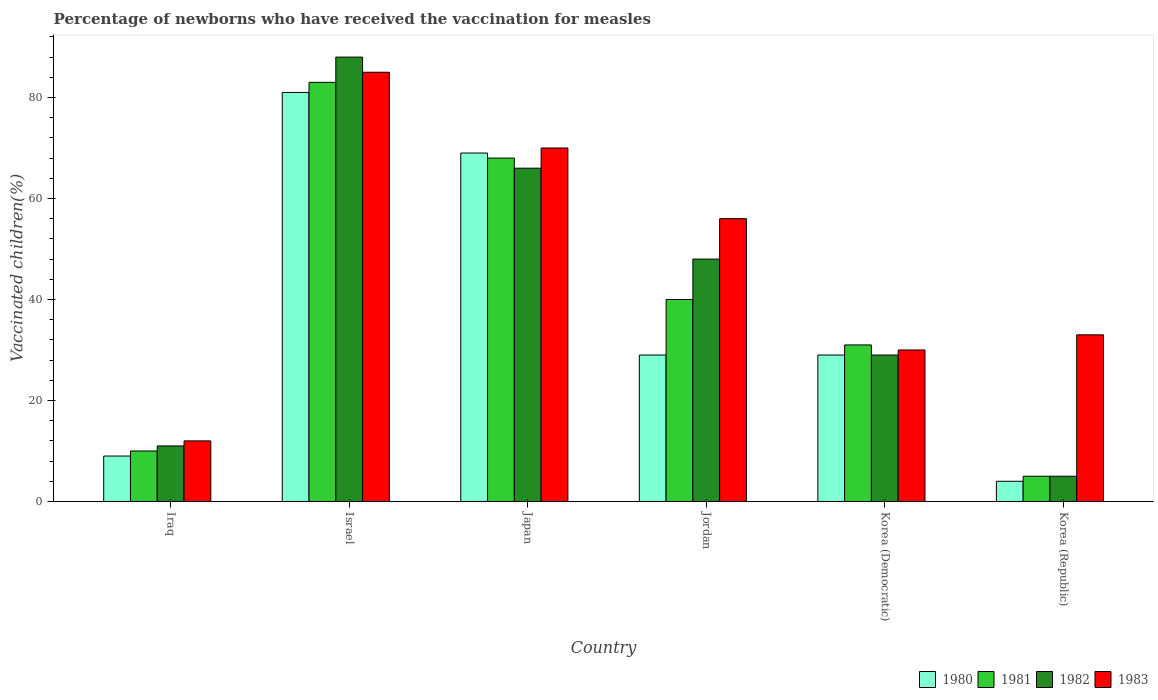How many groups of bars are there?
Make the answer very short. 6. How many bars are there on the 1st tick from the right?
Your answer should be very brief. 4. In how many cases, is the number of bars for a given country not equal to the number of legend labels?
Provide a succinct answer. 0. Across all countries, what is the minimum percentage of vaccinated children in 1982?
Provide a succinct answer. 5. In which country was the percentage of vaccinated children in 1982 minimum?
Your answer should be compact. Korea (Republic). What is the total percentage of vaccinated children in 1981 in the graph?
Offer a very short reply. 237. What is the difference between the percentage of vaccinated children in 1980 in Iraq and the percentage of vaccinated children in 1983 in Jordan?
Offer a terse response. -47. What is the average percentage of vaccinated children in 1983 per country?
Offer a terse response. 47.67. In how many countries, is the percentage of vaccinated children in 1981 greater than 80 %?
Give a very brief answer. 1. In how many countries, is the percentage of vaccinated children in 1981 greater than the average percentage of vaccinated children in 1981 taken over all countries?
Give a very brief answer. 3. Is the sum of the percentage of vaccinated children in 1981 in Iraq and Jordan greater than the maximum percentage of vaccinated children in 1983 across all countries?
Provide a short and direct response. No. How many bars are there?
Offer a very short reply. 24. Are all the bars in the graph horizontal?
Give a very brief answer. No. How many countries are there in the graph?
Your answer should be very brief. 6. Are the values on the major ticks of Y-axis written in scientific E-notation?
Give a very brief answer. No. Does the graph contain grids?
Give a very brief answer. No. How are the legend labels stacked?
Give a very brief answer. Horizontal. What is the title of the graph?
Offer a very short reply. Percentage of newborns who have received the vaccination for measles. What is the label or title of the Y-axis?
Keep it short and to the point. Vaccinated children(%). What is the Vaccinated children(%) in 1980 in Iraq?
Ensure brevity in your answer.  9. What is the Vaccinated children(%) in 1981 in Iraq?
Provide a succinct answer. 10. What is the Vaccinated children(%) of 1980 in Israel?
Make the answer very short. 81. What is the Vaccinated children(%) of 1981 in Israel?
Offer a terse response. 83. What is the Vaccinated children(%) in 1982 in Israel?
Keep it short and to the point. 88. What is the Vaccinated children(%) of 1980 in Japan?
Your answer should be very brief. 69. What is the Vaccinated children(%) in 1981 in Japan?
Give a very brief answer. 68. What is the Vaccinated children(%) of 1983 in Japan?
Make the answer very short. 70. What is the Vaccinated children(%) in 1982 in Jordan?
Give a very brief answer. 48. What is the Vaccinated children(%) in 1980 in Korea (Democratic)?
Your answer should be compact. 29. What is the Vaccinated children(%) in 1981 in Korea (Democratic)?
Give a very brief answer. 31. What is the Vaccinated children(%) in 1982 in Korea (Democratic)?
Ensure brevity in your answer.  29. Across all countries, what is the maximum Vaccinated children(%) of 1980?
Offer a very short reply. 81. Across all countries, what is the maximum Vaccinated children(%) in 1981?
Provide a succinct answer. 83. Across all countries, what is the maximum Vaccinated children(%) of 1982?
Your answer should be very brief. 88. Across all countries, what is the maximum Vaccinated children(%) of 1983?
Provide a short and direct response. 85. Across all countries, what is the minimum Vaccinated children(%) of 1980?
Ensure brevity in your answer.  4. Across all countries, what is the minimum Vaccinated children(%) in 1981?
Offer a terse response. 5. What is the total Vaccinated children(%) of 1980 in the graph?
Make the answer very short. 221. What is the total Vaccinated children(%) in 1981 in the graph?
Make the answer very short. 237. What is the total Vaccinated children(%) of 1982 in the graph?
Provide a succinct answer. 247. What is the total Vaccinated children(%) in 1983 in the graph?
Make the answer very short. 286. What is the difference between the Vaccinated children(%) of 1980 in Iraq and that in Israel?
Provide a short and direct response. -72. What is the difference between the Vaccinated children(%) in 1981 in Iraq and that in Israel?
Your answer should be very brief. -73. What is the difference between the Vaccinated children(%) in 1982 in Iraq and that in Israel?
Give a very brief answer. -77. What is the difference between the Vaccinated children(%) in 1983 in Iraq and that in Israel?
Offer a terse response. -73. What is the difference between the Vaccinated children(%) of 1980 in Iraq and that in Japan?
Provide a succinct answer. -60. What is the difference between the Vaccinated children(%) of 1981 in Iraq and that in Japan?
Ensure brevity in your answer.  -58. What is the difference between the Vaccinated children(%) of 1982 in Iraq and that in Japan?
Give a very brief answer. -55. What is the difference between the Vaccinated children(%) of 1983 in Iraq and that in Japan?
Keep it short and to the point. -58. What is the difference between the Vaccinated children(%) of 1980 in Iraq and that in Jordan?
Offer a very short reply. -20. What is the difference between the Vaccinated children(%) in 1982 in Iraq and that in Jordan?
Give a very brief answer. -37. What is the difference between the Vaccinated children(%) in 1983 in Iraq and that in Jordan?
Offer a very short reply. -44. What is the difference between the Vaccinated children(%) of 1982 in Iraq and that in Korea (Democratic)?
Your response must be concise. -18. What is the difference between the Vaccinated children(%) of 1983 in Iraq and that in Korea (Democratic)?
Provide a succinct answer. -18. What is the difference between the Vaccinated children(%) in 1980 in Iraq and that in Korea (Republic)?
Your answer should be very brief. 5. What is the difference between the Vaccinated children(%) in 1981 in Iraq and that in Korea (Republic)?
Provide a short and direct response. 5. What is the difference between the Vaccinated children(%) of 1982 in Iraq and that in Korea (Republic)?
Your answer should be very brief. 6. What is the difference between the Vaccinated children(%) of 1980 in Israel and that in Japan?
Make the answer very short. 12. What is the difference between the Vaccinated children(%) of 1981 in Israel and that in Japan?
Give a very brief answer. 15. What is the difference between the Vaccinated children(%) of 1980 in Israel and that in Jordan?
Your answer should be very brief. 52. What is the difference between the Vaccinated children(%) in 1983 in Israel and that in Jordan?
Offer a terse response. 29. What is the difference between the Vaccinated children(%) of 1982 in Israel and that in Korea (Democratic)?
Your answer should be compact. 59. What is the difference between the Vaccinated children(%) of 1983 in Israel and that in Korea (Republic)?
Your response must be concise. 52. What is the difference between the Vaccinated children(%) of 1980 in Japan and that in Jordan?
Ensure brevity in your answer.  40. What is the difference between the Vaccinated children(%) of 1981 in Japan and that in Jordan?
Provide a succinct answer. 28. What is the difference between the Vaccinated children(%) in 1982 in Japan and that in Jordan?
Give a very brief answer. 18. What is the difference between the Vaccinated children(%) of 1983 in Japan and that in Jordan?
Make the answer very short. 14. What is the difference between the Vaccinated children(%) of 1980 in Japan and that in Korea (Democratic)?
Provide a succinct answer. 40. What is the difference between the Vaccinated children(%) of 1981 in Japan and that in Korea (Democratic)?
Offer a terse response. 37. What is the difference between the Vaccinated children(%) in 1983 in Japan and that in Korea (Democratic)?
Your answer should be very brief. 40. What is the difference between the Vaccinated children(%) in 1980 in Japan and that in Korea (Republic)?
Make the answer very short. 65. What is the difference between the Vaccinated children(%) in 1981 in Japan and that in Korea (Republic)?
Give a very brief answer. 63. What is the difference between the Vaccinated children(%) of 1982 in Japan and that in Korea (Republic)?
Your answer should be compact. 61. What is the difference between the Vaccinated children(%) in 1983 in Japan and that in Korea (Republic)?
Provide a short and direct response. 37. What is the difference between the Vaccinated children(%) in 1980 in Jordan and that in Korea (Democratic)?
Your answer should be very brief. 0. What is the difference between the Vaccinated children(%) in 1981 in Jordan and that in Korea (Democratic)?
Offer a terse response. 9. What is the difference between the Vaccinated children(%) in 1982 in Jordan and that in Korea (Democratic)?
Offer a terse response. 19. What is the difference between the Vaccinated children(%) of 1983 in Jordan and that in Korea (Democratic)?
Keep it short and to the point. 26. What is the difference between the Vaccinated children(%) of 1981 in Jordan and that in Korea (Republic)?
Make the answer very short. 35. What is the difference between the Vaccinated children(%) of 1982 in Jordan and that in Korea (Republic)?
Provide a short and direct response. 43. What is the difference between the Vaccinated children(%) of 1983 in Jordan and that in Korea (Republic)?
Your response must be concise. 23. What is the difference between the Vaccinated children(%) in 1981 in Korea (Democratic) and that in Korea (Republic)?
Provide a succinct answer. 26. What is the difference between the Vaccinated children(%) of 1982 in Korea (Democratic) and that in Korea (Republic)?
Your answer should be very brief. 24. What is the difference between the Vaccinated children(%) in 1980 in Iraq and the Vaccinated children(%) in 1981 in Israel?
Your answer should be very brief. -74. What is the difference between the Vaccinated children(%) of 1980 in Iraq and the Vaccinated children(%) of 1982 in Israel?
Give a very brief answer. -79. What is the difference between the Vaccinated children(%) in 1980 in Iraq and the Vaccinated children(%) in 1983 in Israel?
Give a very brief answer. -76. What is the difference between the Vaccinated children(%) of 1981 in Iraq and the Vaccinated children(%) of 1982 in Israel?
Your answer should be very brief. -78. What is the difference between the Vaccinated children(%) of 1981 in Iraq and the Vaccinated children(%) of 1983 in Israel?
Your response must be concise. -75. What is the difference between the Vaccinated children(%) in 1982 in Iraq and the Vaccinated children(%) in 1983 in Israel?
Offer a very short reply. -74. What is the difference between the Vaccinated children(%) of 1980 in Iraq and the Vaccinated children(%) of 1981 in Japan?
Provide a succinct answer. -59. What is the difference between the Vaccinated children(%) in 1980 in Iraq and the Vaccinated children(%) in 1982 in Japan?
Provide a short and direct response. -57. What is the difference between the Vaccinated children(%) in 1980 in Iraq and the Vaccinated children(%) in 1983 in Japan?
Keep it short and to the point. -61. What is the difference between the Vaccinated children(%) of 1981 in Iraq and the Vaccinated children(%) of 1982 in Japan?
Your answer should be compact. -56. What is the difference between the Vaccinated children(%) of 1981 in Iraq and the Vaccinated children(%) of 1983 in Japan?
Offer a terse response. -60. What is the difference between the Vaccinated children(%) of 1982 in Iraq and the Vaccinated children(%) of 1983 in Japan?
Offer a very short reply. -59. What is the difference between the Vaccinated children(%) in 1980 in Iraq and the Vaccinated children(%) in 1981 in Jordan?
Provide a succinct answer. -31. What is the difference between the Vaccinated children(%) of 1980 in Iraq and the Vaccinated children(%) of 1982 in Jordan?
Give a very brief answer. -39. What is the difference between the Vaccinated children(%) of 1980 in Iraq and the Vaccinated children(%) of 1983 in Jordan?
Your answer should be compact. -47. What is the difference between the Vaccinated children(%) in 1981 in Iraq and the Vaccinated children(%) in 1982 in Jordan?
Provide a succinct answer. -38. What is the difference between the Vaccinated children(%) in 1981 in Iraq and the Vaccinated children(%) in 1983 in Jordan?
Provide a succinct answer. -46. What is the difference between the Vaccinated children(%) of 1982 in Iraq and the Vaccinated children(%) of 1983 in Jordan?
Your response must be concise. -45. What is the difference between the Vaccinated children(%) in 1981 in Iraq and the Vaccinated children(%) in 1983 in Korea (Democratic)?
Your response must be concise. -20. What is the difference between the Vaccinated children(%) of 1980 in Iraq and the Vaccinated children(%) of 1982 in Korea (Republic)?
Provide a succinct answer. 4. What is the difference between the Vaccinated children(%) of 1981 in Iraq and the Vaccinated children(%) of 1982 in Korea (Republic)?
Provide a succinct answer. 5. What is the difference between the Vaccinated children(%) of 1981 in Iraq and the Vaccinated children(%) of 1983 in Korea (Republic)?
Offer a terse response. -23. What is the difference between the Vaccinated children(%) in 1980 in Israel and the Vaccinated children(%) in 1982 in Japan?
Make the answer very short. 15. What is the difference between the Vaccinated children(%) in 1980 in Israel and the Vaccinated children(%) in 1983 in Japan?
Give a very brief answer. 11. What is the difference between the Vaccinated children(%) of 1981 in Israel and the Vaccinated children(%) of 1983 in Japan?
Your answer should be very brief. 13. What is the difference between the Vaccinated children(%) of 1982 in Israel and the Vaccinated children(%) of 1983 in Japan?
Ensure brevity in your answer.  18. What is the difference between the Vaccinated children(%) in 1980 in Israel and the Vaccinated children(%) in 1981 in Jordan?
Offer a very short reply. 41. What is the difference between the Vaccinated children(%) of 1980 in Israel and the Vaccinated children(%) of 1982 in Jordan?
Offer a very short reply. 33. What is the difference between the Vaccinated children(%) of 1980 in Israel and the Vaccinated children(%) of 1983 in Jordan?
Provide a succinct answer. 25. What is the difference between the Vaccinated children(%) of 1981 in Israel and the Vaccinated children(%) of 1982 in Jordan?
Your answer should be compact. 35. What is the difference between the Vaccinated children(%) in 1980 in Israel and the Vaccinated children(%) in 1981 in Korea (Democratic)?
Give a very brief answer. 50. What is the difference between the Vaccinated children(%) in 1981 in Israel and the Vaccinated children(%) in 1982 in Korea (Democratic)?
Offer a terse response. 54. What is the difference between the Vaccinated children(%) in 1981 in Israel and the Vaccinated children(%) in 1983 in Korea (Democratic)?
Ensure brevity in your answer.  53. What is the difference between the Vaccinated children(%) of 1980 in Israel and the Vaccinated children(%) of 1982 in Korea (Republic)?
Provide a succinct answer. 76. What is the difference between the Vaccinated children(%) of 1981 in Israel and the Vaccinated children(%) of 1982 in Korea (Republic)?
Give a very brief answer. 78. What is the difference between the Vaccinated children(%) of 1981 in Israel and the Vaccinated children(%) of 1983 in Korea (Republic)?
Your response must be concise. 50. What is the difference between the Vaccinated children(%) of 1980 in Japan and the Vaccinated children(%) of 1981 in Jordan?
Give a very brief answer. 29. What is the difference between the Vaccinated children(%) of 1980 in Japan and the Vaccinated children(%) of 1982 in Jordan?
Give a very brief answer. 21. What is the difference between the Vaccinated children(%) in 1980 in Japan and the Vaccinated children(%) in 1983 in Jordan?
Provide a succinct answer. 13. What is the difference between the Vaccinated children(%) in 1981 in Japan and the Vaccinated children(%) in 1982 in Jordan?
Offer a very short reply. 20. What is the difference between the Vaccinated children(%) of 1981 in Japan and the Vaccinated children(%) of 1983 in Korea (Democratic)?
Ensure brevity in your answer.  38. What is the difference between the Vaccinated children(%) of 1980 in Japan and the Vaccinated children(%) of 1981 in Korea (Republic)?
Offer a terse response. 64. What is the difference between the Vaccinated children(%) of 1980 in Japan and the Vaccinated children(%) of 1983 in Korea (Republic)?
Your answer should be very brief. 36. What is the difference between the Vaccinated children(%) of 1981 in Japan and the Vaccinated children(%) of 1982 in Korea (Republic)?
Provide a succinct answer. 63. What is the difference between the Vaccinated children(%) of 1981 in Jordan and the Vaccinated children(%) of 1982 in Korea (Democratic)?
Keep it short and to the point. 11. What is the difference between the Vaccinated children(%) of 1980 in Jordan and the Vaccinated children(%) of 1983 in Korea (Republic)?
Offer a terse response. -4. What is the difference between the Vaccinated children(%) of 1981 in Jordan and the Vaccinated children(%) of 1982 in Korea (Republic)?
Your answer should be compact. 35. What is the difference between the Vaccinated children(%) of 1980 in Korea (Democratic) and the Vaccinated children(%) of 1982 in Korea (Republic)?
Offer a terse response. 24. What is the difference between the Vaccinated children(%) in 1981 in Korea (Democratic) and the Vaccinated children(%) in 1982 in Korea (Republic)?
Provide a succinct answer. 26. What is the difference between the Vaccinated children(%) of 1982 in Korea (Democratic) and the Vaccinated children(%) of 1983 in Korea (Republic)?
Provide a short and direct response. -4. What is the average Vaccinated children(%) in 1980 per country?
Keep it short and to the point. 36.83. What is the average Vaccinated children(%) in 1981 per country?
Your response must be concise. 39.5. What is the average Vaccinated children(%) in 1982 per country?
Your answer should be very brief. 41.17. What is the average Vaccinated children(%) in 1983 per country?
Your answer should be compact. 47.67. What is the difference between the Vaccinated children(%) of 1981 and Vaccinated children(%) of 1983 in Iraq?
Offer a very short reply. -2. What is the difference between the Vaccinated children(%) in 1982 and Vaccinated children(%) in 1983 in Iraq?
Provide a succinct answer. -1. What is the difference between the Vaccinated children(%) in 1980 and Vaccinated children(%) in 1982 in Japan?
Make the answer very short. 3. What is the difference between the Vaccinated children(%) of 1980 and Vaccinated children(%) of 1983 in Japan?
Your answer should be very brief. -1. What is the difference between the Vaccinated children(%) in 1981 and Vaccinated children(%) in 1982 in Japan?
Provide a succinct answer. 2. What is the difference between the Vaccinated children(%) of 1981 and Vaccinated children(%) of 1983 in Japan?
Your answer should be very brief. -2. What is the difference between the Vaccinated children(%) in 1982 and Vaccinated children(%) in 1983 in Japan?
Your response must be concise. -4. What is the difference between the Vaccinated children(%) in 1982 and Vaccinated children(%) in 1983 in Jordan?
Your answer should be compact. -8. What is the difference between the Vaccinated children(%) in 1980 and Vaccinated children(%) in 1983 in Korea (Democratic)?
Ensure brevity in your answer.  -1. What is the difference between the Vaccinated children(%) of 1981 and Vaccinated children(%) of 1982 in Korea (Democratic)?
Provide a short and direct response. 2. What is the difference between the Vaccinated children(%) of 1982 and Vaccinated children(%) of 1983 in Korea (Democratic)?
Your answer should be compact. -1. What is the difference between the Vaccinated children(%) in 1980 and Vaccinated children(%) in 1983 in Korea (Republic)?
Provide a succinct answer. -29. What is the difference between the Vaccinated children(%) in 1981 and Vaccinated children(%) in 1982 in Korea (Republic)?
Offer a terse response. 0. What is the difference between the Vaccinated children(%) of 1981 and Vaccinated children(%) of 1983 in Korea (Republic)?
Offer a terse response. -28. What is the difference between the Vaccinated children(%) in 1982 and Vaccinated children(%) in 1983 in Korea (Republic)?
Provide a short and direct response. -28. What is the ratio of the Vaccinated children(%) of 1980 in Iraq to that in Israel?
Your response must be concise. 0.11. What is the ratio of the Vaccinated children(%) of 1981 in Iraq to that in Israel?
Provide a short and direct response. 0.12. What is the ratio of the Vaccinated children(%) of 1983 in Iraq to that in Israel?
Keep it short and to the point. 0.14. What is the ratio of the Vaccinated children(%) of 1980 in Iraq to that in Japan?
Ensure brevity in your answer.  0.13. What is the ratio of the Vaccinated children(%) of 1981 in Iraq to that in Japan?
Make the answer very short. 0.15. What is the ratio of the Vaccinated children(%) in 1983 in Iraq to that in Japan?
Your answer should be very brief. 0.17. What is the ratio of the Vaccinated children(%) of 1980 in Iraq to that in Jordan?
Keep it short and to the point. 0.31. What is the ratio of the Vaccinated children(%) of 1981 in Iraq to that in Jordan?
Provide a short and direct response. 0.25. What is the ratio of the Vaccinated children(%) in 1982 in Iraq to that in Jordan?
Ensure brevity in your answer.  0.23. What is the ratio of the Vaccinated children(%) of 1983 in Iraq to that in Jordan?
Provide a short and direct response. 0.21. What is the ratio of the Vaccinated children(%) in 1980 in Iraq to that in Korea (Democratic)?
Make the answer very short. 0.31. What is the ratio of the Vaccinated children(%) in 1981 in Iraq to that in Korea (Democratic)?
Offer a terse response. 0.32. What is the ratio of the Vaccinated children(%) in 1982 in Iraq to that in Korea (Democratic)?
Your answer should be compact. 0.38. What is the ratio of the Vaccinated children(%) of 1980 in Iraq to that in Korea (Republic)?
Provide a short and direct response. 2.25. What is the ratio of the Vaccinated children(%) in 1983 in Iraq to that in Korea (Republic)?
Make the answer very short. 0.36. What is the ratio of the Vaccinated children(%) in 1980 in Israel to that in Japan?
Offer a terse response. 1.17. What is the ratio of the Vaccinated children(%) in 1981 in Israel to that in Japan?
Your response must be concise. 1.22. What is the ratio of the Vaccinated children(%) in 1982 in Israel to that in Japan?
Your answer should be compact. 1.33. What is the ratio of the Vaccinated children(%) in 1983 in Israel to that in Japan?
Give a very brief answer. 1.21. What is the ratio of the Vaccinated children(%) in 1980 in Israel to that in Jordan?
Offer a very short reply. 2.79. What is the ratio of the Vaccinated children(%) in 1981 in Israel to that in Jordan?
Give a very brief answer. 2.08. What is the ratio of the Vaccinated children(%) of 1982 in Israel to that in Jordan?
Give a very brief answer. 1.83. What is the ratio of the Vaccinated children(%) in 1983 in Israel to that in Jordan?
Keep it short and to the point. 1.52. What is the ratio of the Vaccinated children(%) in 1980 in Israel to that in Korea (Democratic)?
Ensure brevity in your answer.  2.79. What is the ratio of the Vaccinated children(%) in 1981 in Israel to that in Korea (Democratic)?
Make the answer very short. 2.68. What is the ratio of the Vaccinated children(%) of 1982 in Israel to that in Korea (Democratic)?
Make the answer very short. 3.03. What is the ratio of the Vaccinated children(%) in 1983 in Israel to that in Korea (Democratic)?
Your response must be concise. 2.83. What is the ratio of the Vaccinated children(%) of 1980 in Israel to that in Korea (Republic)?
Offer a very short reply. 20.25. What is the ratio of the Vaccinated children(%) of 1982 in Israel to that in Korea (Republic)?
Provide a short and direct response. 17.6. What is the ratio of the Vaccinated children(%) of 1983 in Israel to that in Korea (Republic)?
Your response must be concise. 2.58. What is the ratio of the Vaccinated children(%) in 1980 in Japan to that in Jordan?
Provide a short and direct response. 2.38. What is the ratio of the Vaccinated children(%) in 1982 in Japan to that in Jordan?
Offer a very short reply. 1.38. What is the ratio of the Vaccinated children(%) in 1980 in Japan to that in Korea (Democratic)?
Offer a very short reply. 2.38. What is the ratio of the Vaccinated children(%) of 1981 in Japan to that in Korea (Democratic)?
Give a very brief answer. 2.19. What is the ratio of the Vaccinated children(%) in 1982 in Japan to that in Korea (Democratic)?
Ensure brevity in your answer.  2.28. What is the ratio of the Vaccinated children(%) in 1983 in Japan to that in Korea (Democratic)?
Your answer should be very brief. 2.33. What is the ratio of the Vaccinated children(%) in 1980 in Japan to that in Korea (Republic)?
Your answer should be very brief. 17.25. What is the ratio of the Vaccinated children(%) of 1981 in Japan to that in Korea (Republic)?
Offer a terse response. 13.6. What is the ratio of the Vaccinated children(%) in 1983 in Japan to that in Korea (Republic)?
Your answer should be compact. 2.12. What is the ratio of the Vaccinated children(%) in 1980 in Jordan to that in Korea (Democratic)?
Give a very brief answer. 1. What is the ratio of the Vaccinated children(%) in 1981 in Jordan to that in Korea (Democratic)?
Offer a terse response. 1.29. What is the ratio of the Vaccinated children(%) of 1982 in Jordan to that in Korea (Democratic)?
Ensure brevity in your answer.  1.66. What is the ratio of the Vaccinated children(%) of 1983 in Jordan to that in Korea (Democratic)?
Make the answer very short. 1.87. What is the ratio of the Vaccinated children(%) of 1980 in Jordan to that in Korea (Republic)?
Your answer should be compact. 7.25. What is the ratio of the Vaccinated children(%) in 1982 in Jordan to that in Korea (Republic)?
Your answer should be very brief. 9.6. What is the ratio of the Vaccinated children(%) of 1983 in Jordan to that in Korea (Republic)?
Your answer should be compact. 1.7. What is the ratio of the Vaccinated children(%) in 1980 in Korea (Democratic) to that in Korea (Republic)?
Give a very brief answer. 7.25. What is the ratio of the Vaccinated children(%) in 1981 in Korea (Democratic) to that in Korea (Republic)?
Make the answer very short. 6.2. What is the ratio of the Vaccinated children(%) in 1982 in Korea (Democratic) to that in Korea (Republic)?
Provide a short and direct response. 5.8. What is the difference between the highest and the second highest Vaccinated children(%) of 1981?
Make the answer very short. 15. What is the difference between the highest and the second highest Vaccinated children(%) in 1982?
Give a very brief answer. 22. What is the difference between the highest and the lowest Vaccinated children(%) of 1981?
Give a very brief answer. 78. What is the difference between the highest and the lowest Vaccinated children(%) of 1983?
Offer a very short reply. 73. 